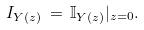<formula> <loc_0><loc_0><loc_500><loc_500>I _ { Y ( z ) } \, = \, \mathbb { I } _ { Y ( z ) } | _ { z = 0 } .</formula> 